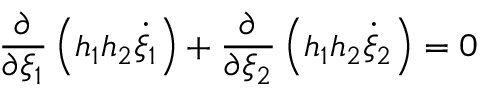<formula> <loc_0><loc_0><loc_500><loc_500>\frac { \partial } { \partial \xi _ { 1 } } \left ( h _ { 1 } h _ { 2 } \dot { \xi } _ { 1 } \right ) + \frac { \partial } { \partial \xi _ { 2 } } \left ( h _ { 1 } h _ { 2 } \dot { \xi } _ { 2 } \right ) = 0</formula> 